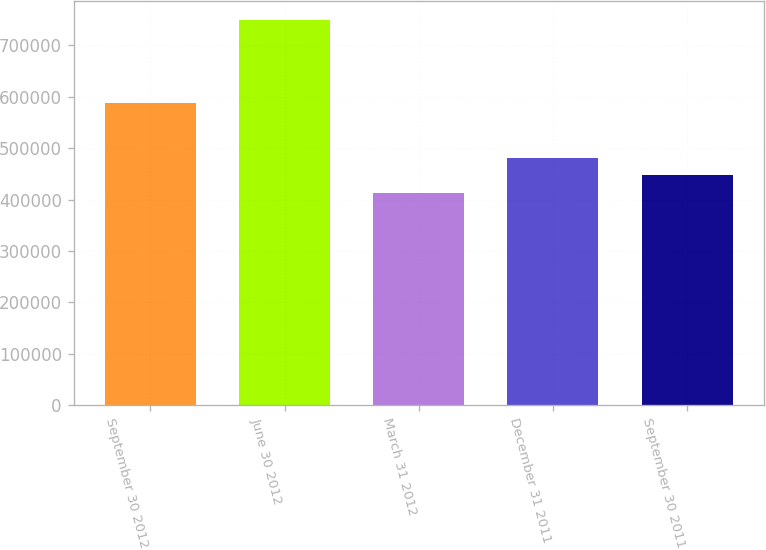Convert chart to OTSL. <chart><loc_0><loc_0><loc_500><loc_500><bar_chart><fcel>September 30 2012<fcel>June 30 2012<fcel>March 31 2012<fcel>December 31 2011<fcel>September 30 2011<nl><fcel>588740<fcel>748569<fcel>413527<fcel>480535<fcel>447031<nl></chart> 